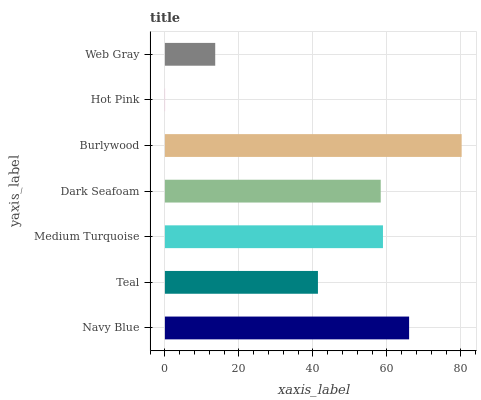Is Hot Pink the minimum?
Answer yes or no. Yes. Is Burlywood the maximum?
Answer yes or no. Yes. Is Teal the minimum?
Answer yes or no. No. Is Teal the maximum?
Answer yes or no. No. Is Navy Blue greater than Teal?
Answer yes or no. Yes. Is Teal less than Navy Blue?
Answer yes or no. Yes. Is Teal greater than Navy Blue?
Answer yes or no. No. Is Navy Blue less than Teal?
Answer yes or no. No. Is Dark Seafoam the high median?
Answer yes or no. Yes. Is Dark Seafoam the low median?
Answer yes or no. Yes. Is Web Gray the high median?
Answer yes or no. No. Is Navy Blue the low median?
Answer yes or no. No. 